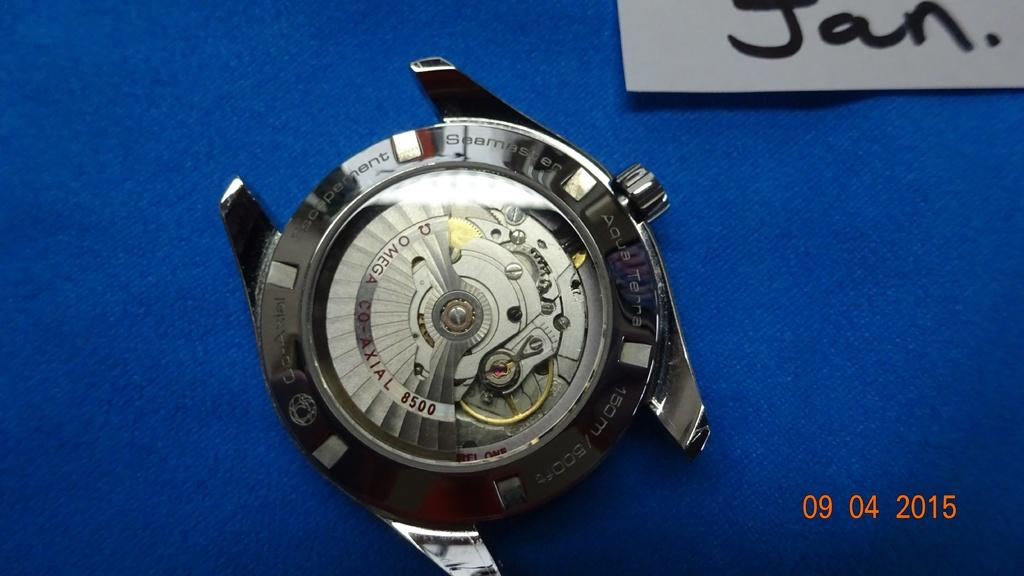<image>
Describe the image concisely. A watch is on a blue cloth under a sign that says Jan. 